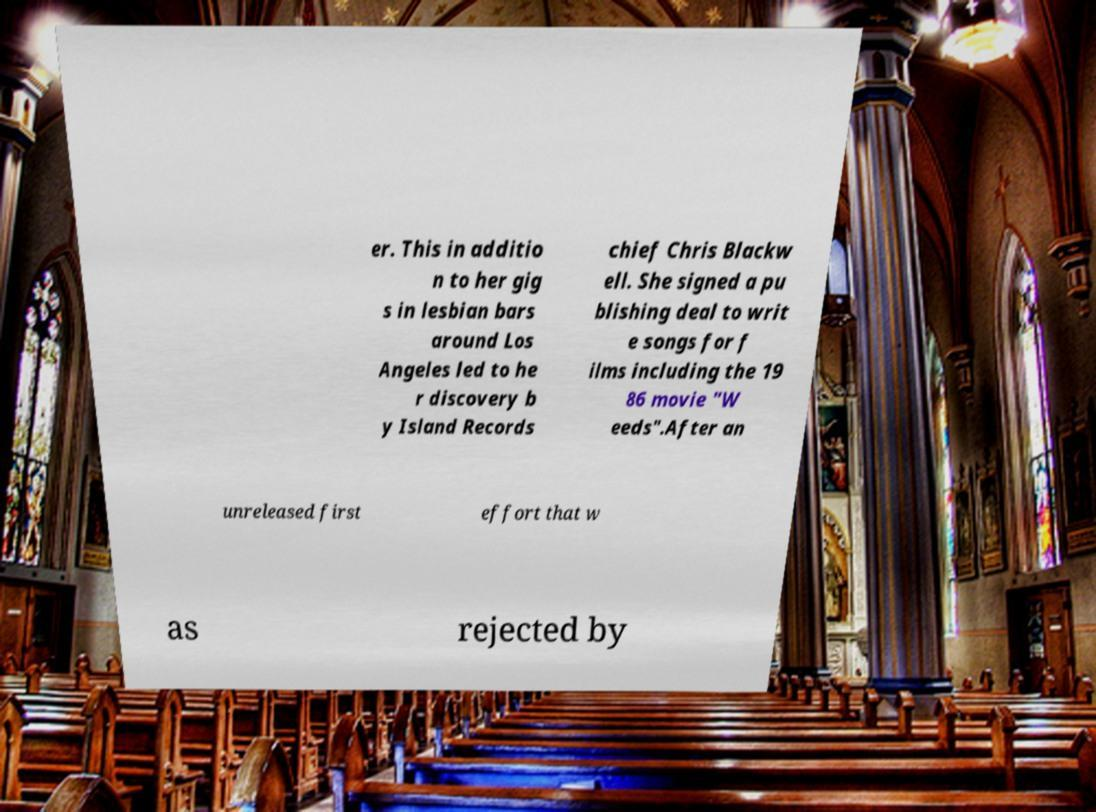For documentation purposes, I need the text within this image transcribed. Could you provide that? er. This in additio n to her gig s in lesbian bars around Los Angeles led to he r discovery b y Island Records chief Chris Blackw ell. She signed a pu blishing deal to writ e songs for f ilms including the 19 86 movie "W eeds".After an unreleased first effort that w as rejected by 